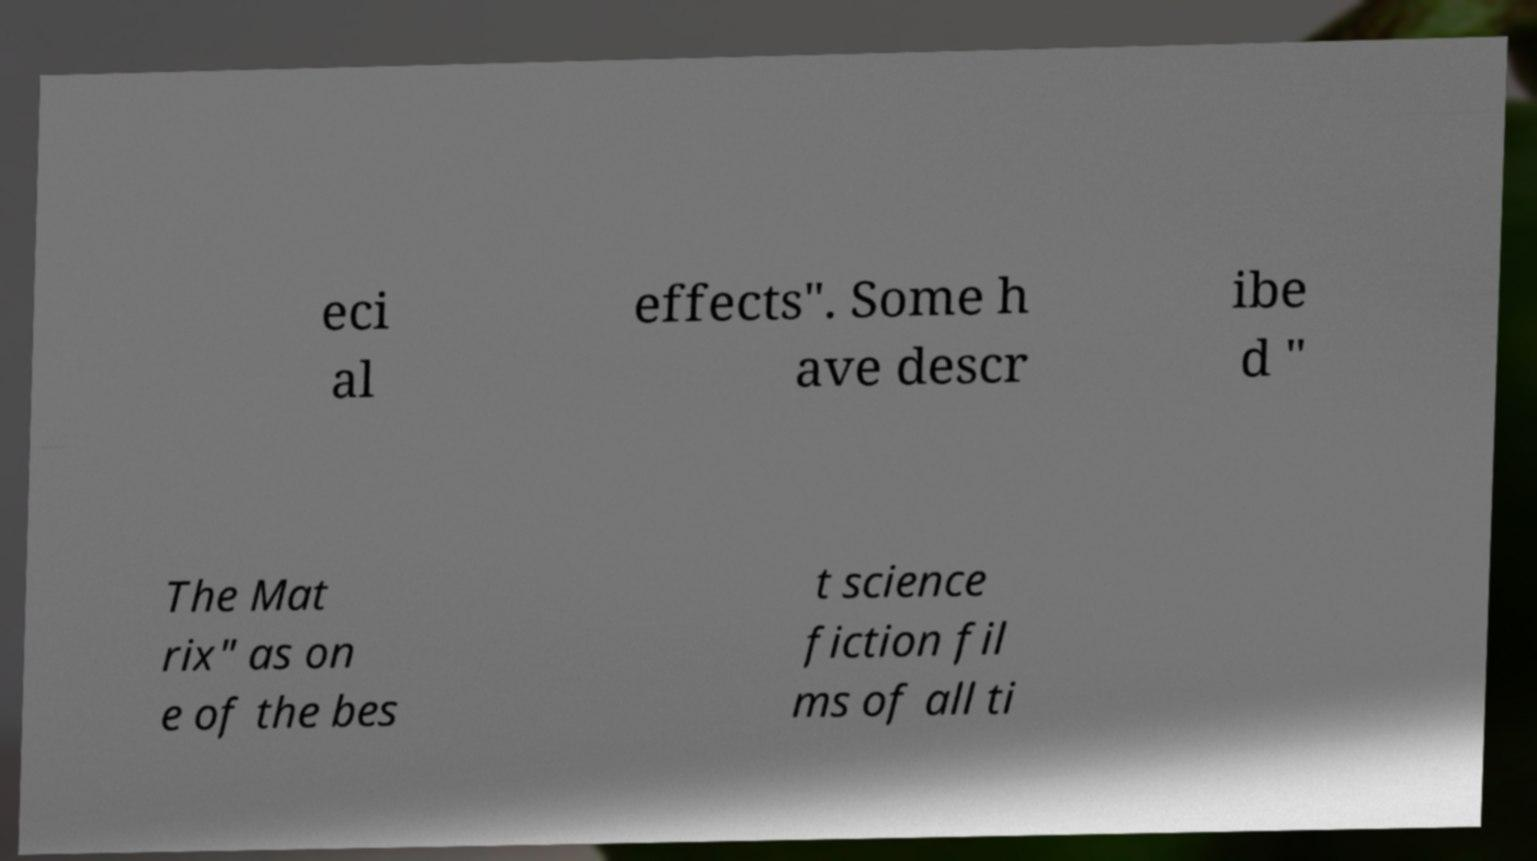Can you read and provide the text displayed in the image?This photo seems to have some interesting text. Can you extract and type it out for me? eci al effects". Some h ave descr ibe d " The Mat rix" as on e of the bes t science fiction fil ms of all ti 